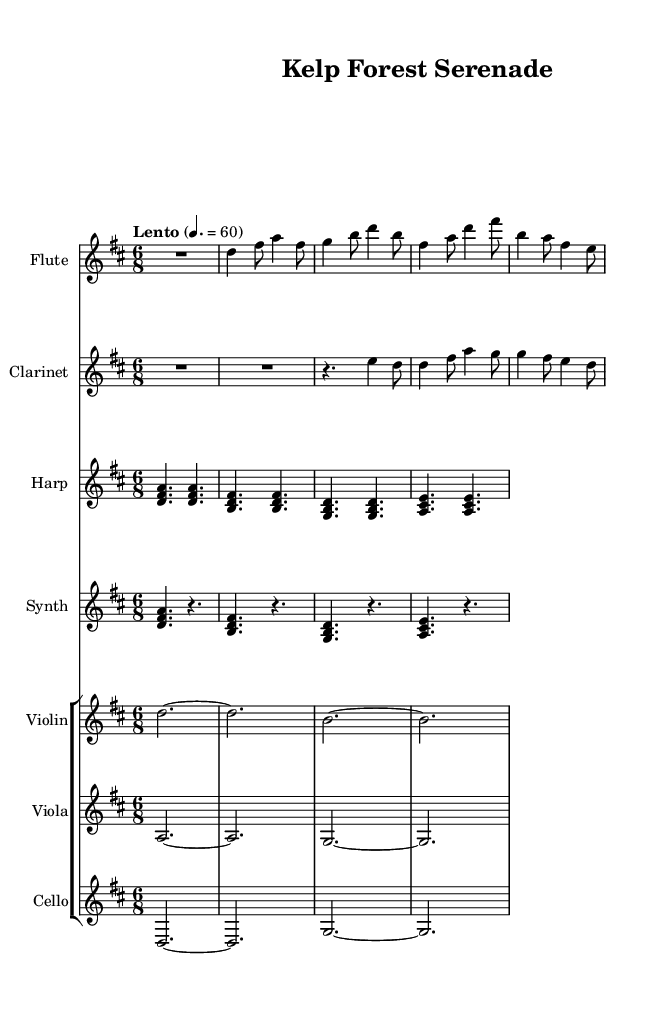What is the key signature of this music? The key signature is indicated by the sharps or flats at the beginning of the staff. In this case, there is an F sharp and a C sharp, indicating the key of D major.
Answer: D major What is the time signature of this piece? The time signature is found at the beginning of the staff, shown as a fraction. Here, it is written as 6 over 8, meaning there are six eighth notes in each measure.
Answer: 6/8 What is the tempo marking indicated in the sheet music? The tempo marking, usually placed at the beginning under the title, shows the intended speed of the piece. It states "Lento" which means slowly, with a metronome marking of 60 beats per minute.
Answer: Lento How many measures are there in this composition? By counting the number of distinct sets of bars in the sheet music, we can determine the number of measures. In this case, there are a total of 12 measures.
Answer: 12 Which instrument has the highest pitch in this arrangement? To find this, we look at the ranges of the instruments and their written parts. The flute part is in a higher octave than the other instruments, making it the highest in pitch.
Answer: Flute In what way does the harp contribute to the ambient soundscape? The harp primarily provides harmonic support and creates a lush, ethereal texture through its sustained chords, enhancing the underwater theme.
Answer: Harmonic support What is the ending dynamic marking for the cello part? The ending dynamic marking can be found at the conclusion of the cello section, which is marked as "p" indicating piano or soft volume.
Answer: p 